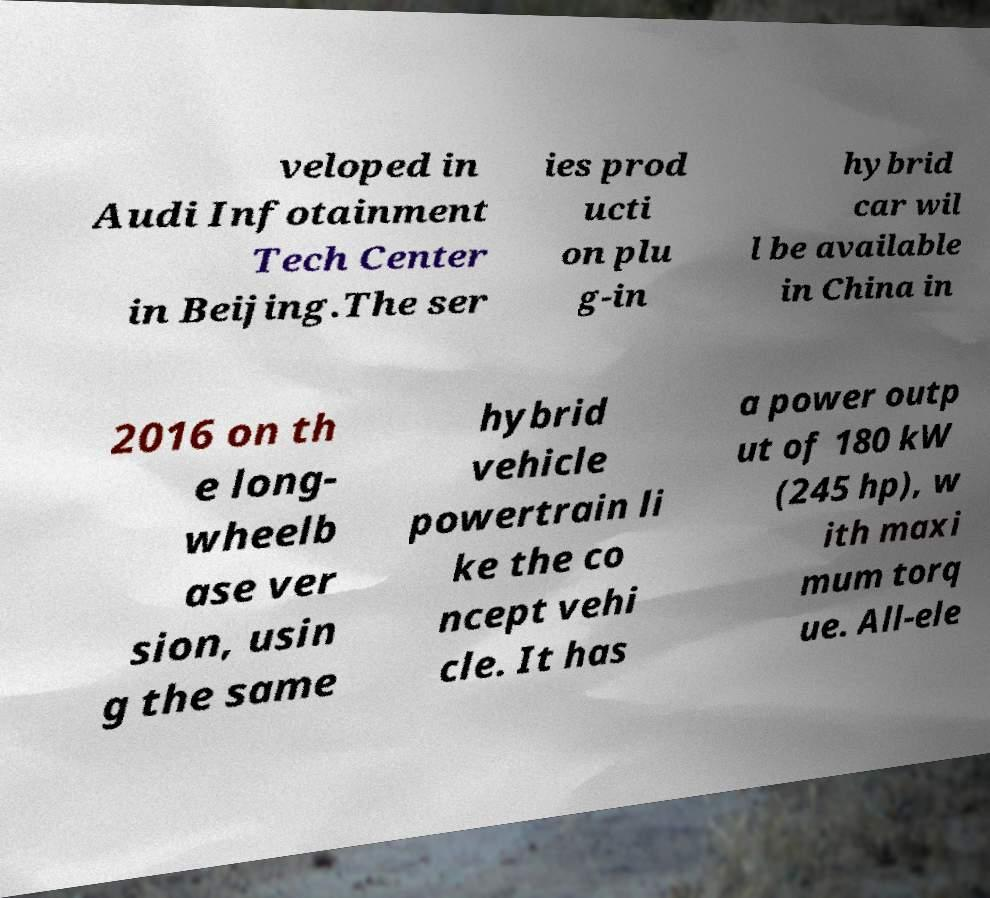Please identify and transcribe the text found in this image. veloped in Audi Infotainment Tech Center in Beijing.The ser ies prod ucti on plu g-in hybrid car wil l be available in China in 2016 on th e long- wheelb ase ver sion, usin g the same hybrid vehicle powertrain li ke the co ncept vehi cle. It has a power outp ut of 180 kW (245 hp), w ith maxi mum torq ue. All-ele 